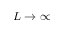Convert formula to latex. <formula><loc_0><loc_0><loc_500><loc_500>L \rightarrow \infty</formula> 